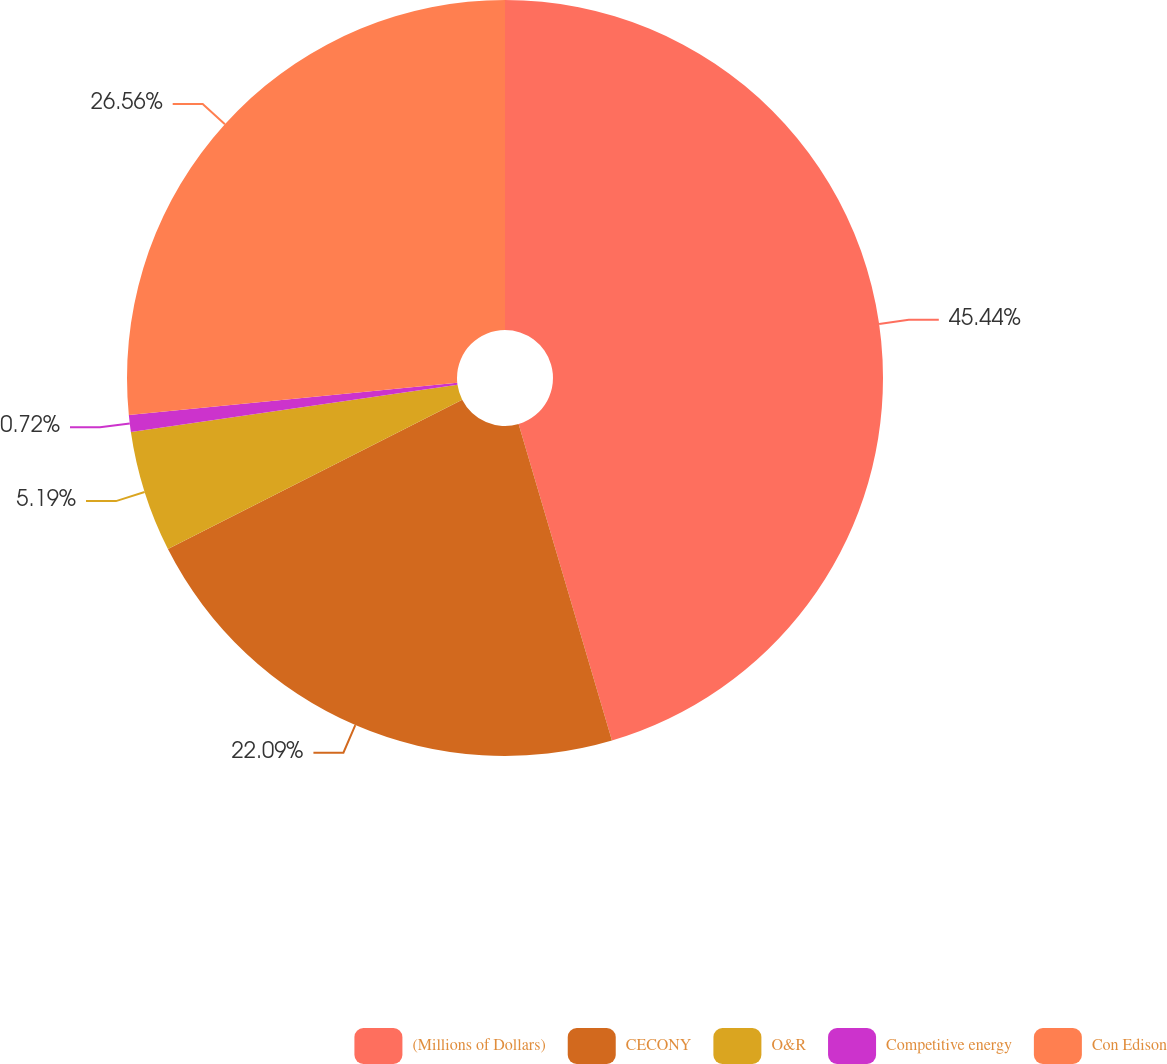<chart> <loc_0><loc_0><loc_500><loc_500><pie_chart><fcel>(Millions of Dollars)<fcel>CECONY<fcel>O&R<fcel>Competitive energy<fcel>Con Edison<nl><fcel>45.43%<fcel>22.09%<fcel>5.19%<fcel>0.72%<fcel>26.56%<nl></chart> 